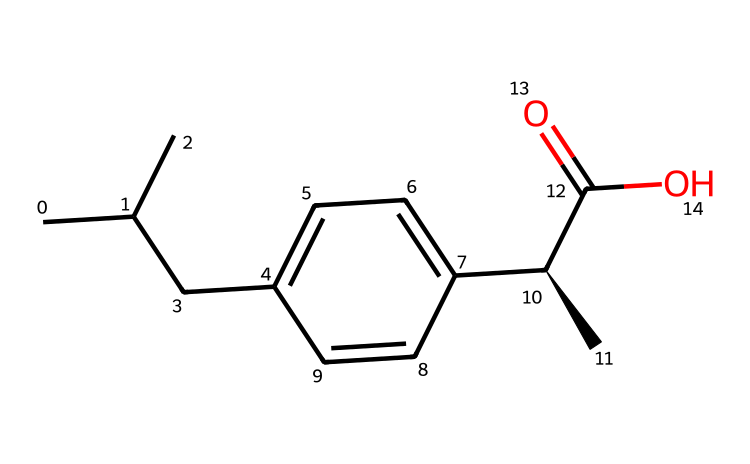What is the chemical name of this structure? The SMILES representation shows that this compound is ibuprofen, a well-known nonsteroidal anti-inflammatory drug (NSAID) used to reduce pain and inflammation.
Answer: ibuprofen How many carbon atoms are present? By analyzing the provided SMILES, we can count the carbon atoms. There are 13 carbon atoms present in the entire structure as denoted by the “C” and the branching structure.
Answer: 13 What type of functional group is present in the structure? The structural representation includes a carboxylic acid group (–COOH) which is indicated by the “C(=O)O” part in the SMILES. This functional group is characteristic of ibuprofen, allowing its classification as an acidic compound.
Answer: carboxylic acid How many double bonds are in the structure? On examining the SMILES closely, there is one carbonyl double bond between the carbon and oxygen (C=O) in the carboxylic acid group, and one double bond implied in the aromatic ring, leading to a total of two double bonds in the structure.
Answer: 2 What is the main role of ibuprofen as indicated by its structure? The presence of the carboxylic acid functional group in ibuprofen is key for its role as a pain reliever as it interacts with enzymes involved in the inflammation pathway, demonstrating its pharmacological action.
Answer: pain reliever What is the stereochemistry of ibuprofen? The SMILES includes “[C@H]” suggesting that there is a specific chiral center in the structure of ibuprofen. This notation indicates the molecule has a specific three-dimensional arrangement that is important for its biological activity.
Answer: chiral 